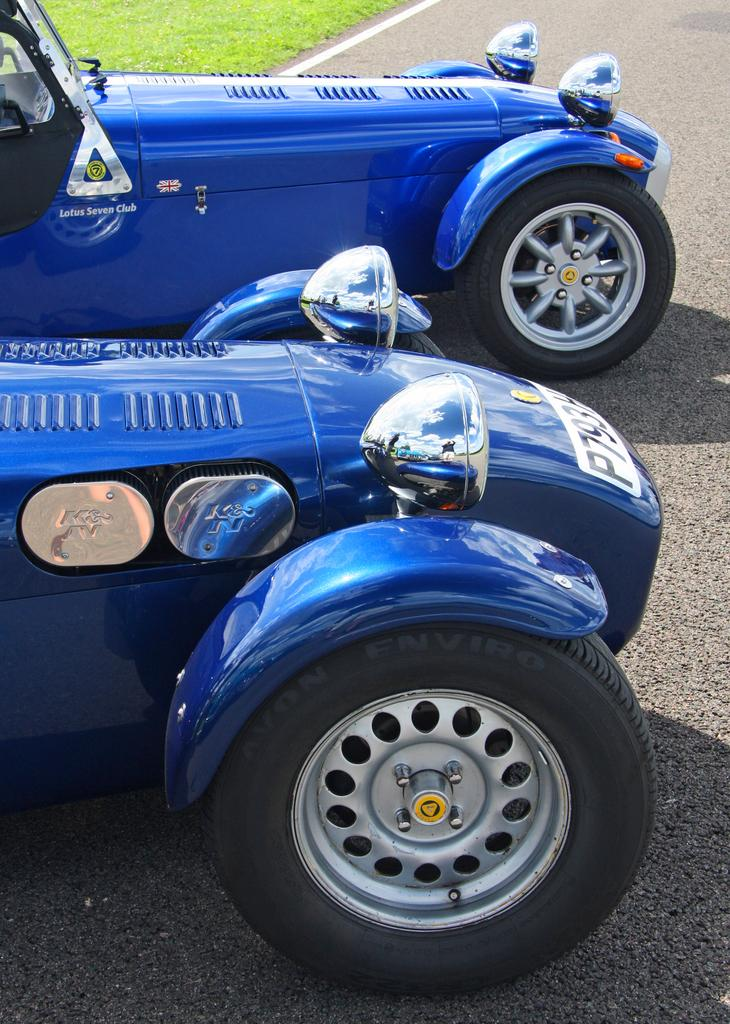What color are the vehicles in the image? The vehicles in the image are blue. How many vehicles can be seen in the image? There are two vehicles in the image. Where are the vehicles located? The vehicles are on the road. What type of vegetation is visible in the image? There is grass visible in the image. Is there a stage set up in the wilderness for a performance in the image? There is no stage or wilderness present in the image; it features two blue vehicles on the road with grass visible. 